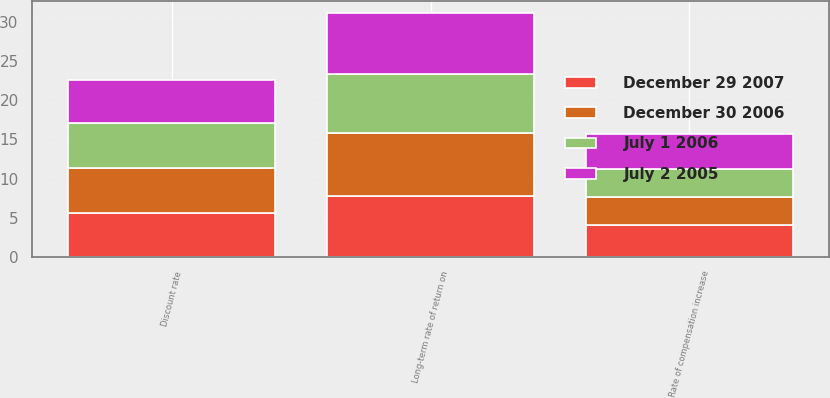<chart> <loc_0><loc_0><loc_500><loc_500><stacked_bar_chart><ecel><fcel>Discount rate<fcel>Long-term rate of return on<fcel>Rate of compensation increase<nl><fcel>December 30 2006<fcel>5.8<fcel>8.03<fcel>3.63<nl><fcel>July 1 2006<fcel>5.77<fcel>7.57<fcel>3.6<nl><fcel>December 29 2007<fcel>5.6<fcel>7.76<fcel>4<nl><fcel>July 2 2005<fcel>5.5<fcel>7.83<fcel>4.5<nl></chart> 